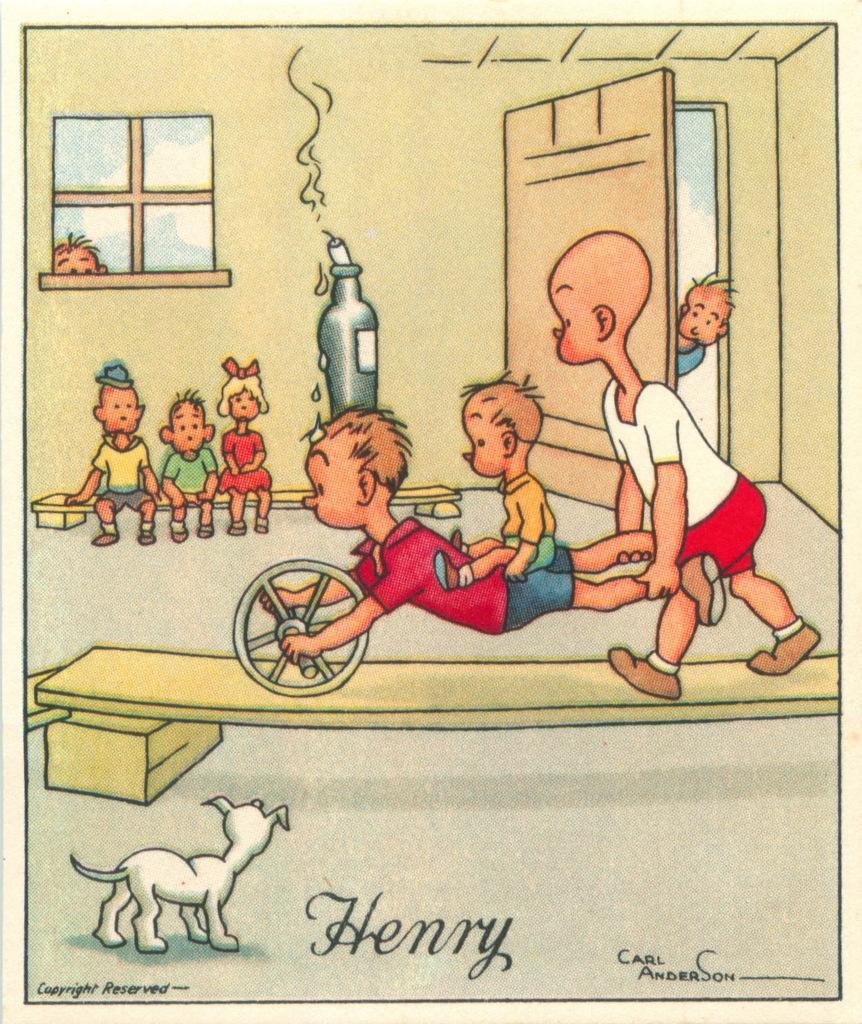Please provide a concise description of this image. It is an animated image, in a room there are group of kids and they are performing some activity and beside the kids there is a dog. 